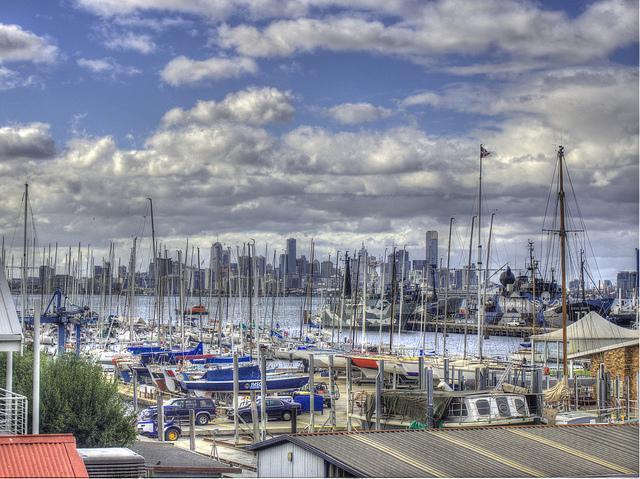How many boats are there?
Give a very brief answer. 2. 